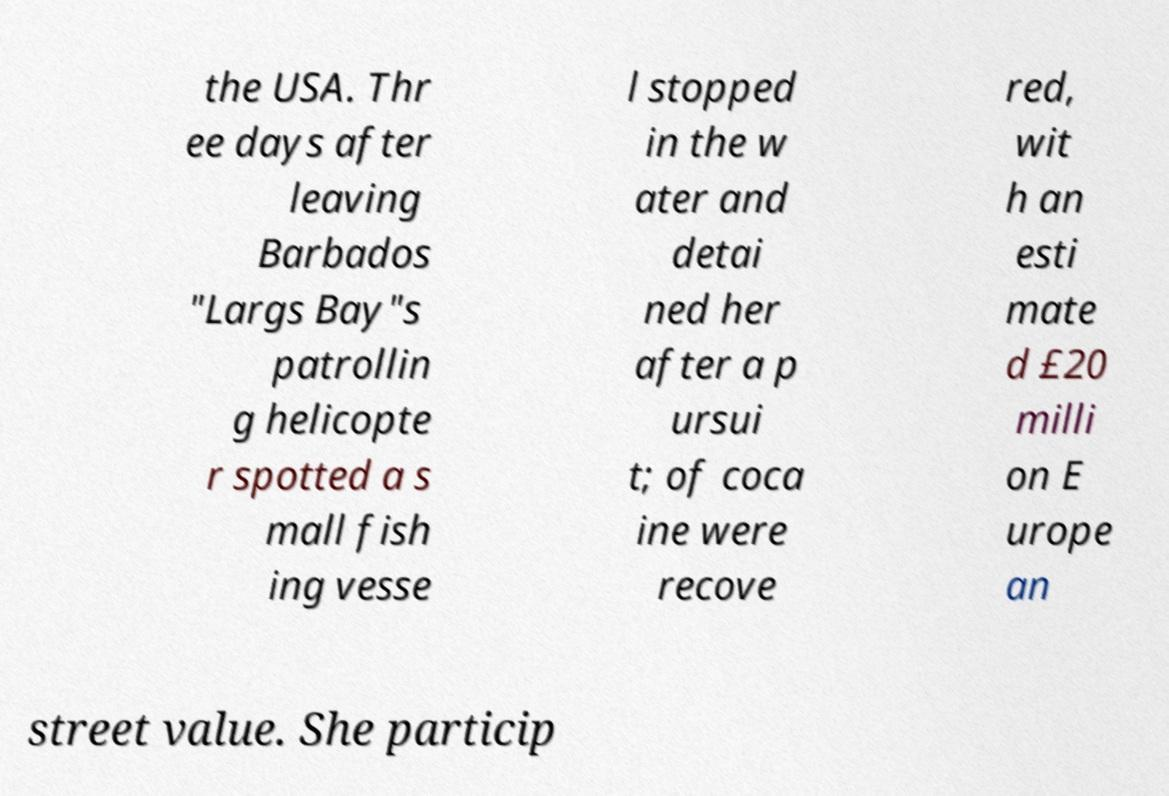For documentation purposes, I need the text within this image transcribed. Could you provide that? the USA. Thr ee days after leaving Barbados "Largs Bay"s patrollin g helicopte r spotted a s mall fish ing vesse l stopped in the w ater and detai ned her after a p ursui t; of coca ine were recove red, wit h an esti mate d £20 milli on E urope an street value. She particip 